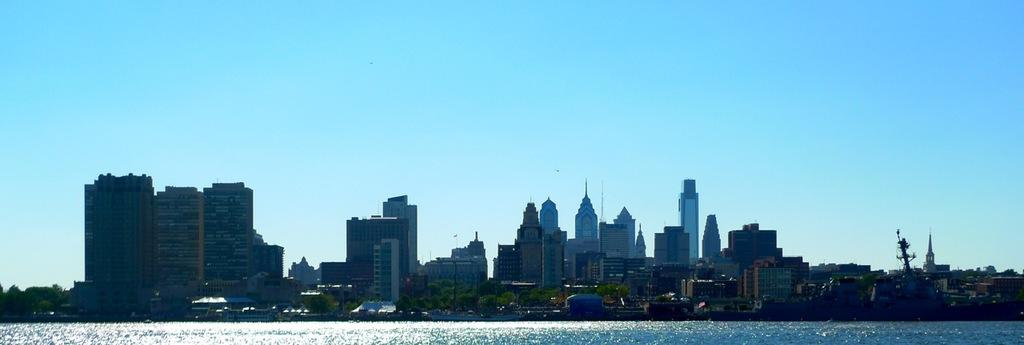What is visible in the image? Water is visible in the image. What can be seen in the background of the image? There are trees, buildings, and light poles in the background of the image. What color are the trees in the image? The trees are green. What is the color of the sky in the image? The sky is blue. How many snails can be seen crawling on the creator's hand in the image? There is no creator or snails present in the image. 